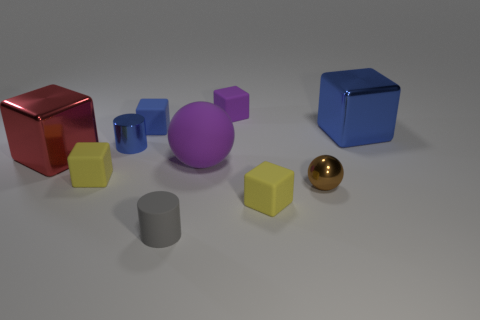Subtract all red blocks. How many blocks are left? 5 Subtract all large red shiny cubes. How many cubes are left? 5 Subtract all brown blocks. Subtract all purple balls. How many blocks are left? 6 Subtract all cubes. How many objects are left? 4 Add 1 purple matte spheres. How many purple matte spheres exist? 2 Subtract 0 red cylinders. How many objects are left? 10 Subtract all large red rubber cylinders. Subtract all small blue metal cylinders. How many objects are left? 9 Add 2 big red shiny things. How many big red shiny things are left? 3 